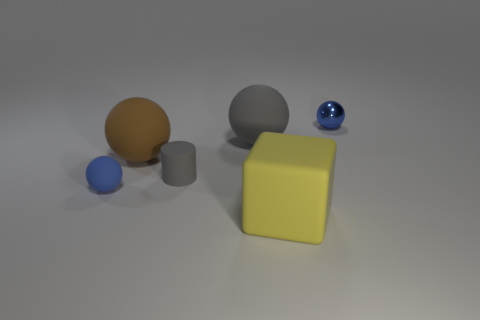Subtract all large brown balls. How many balls are left? 3 Add 2 brown balls. How many objects exist? 8 Subtract all gray cylinders. How many blue balls are left? 2 Subtract 1 blocks. How many blocks are left? 0 Subtract all cylinders. How many objects are left? 5 Subtract all blue spheres. How many spheres are left? 2 Subtract 1 brown spheres. How many objects are left? 5 Subtract all brown spheres. Subtract all blue cubes. How many spheres are left? 3 Subtract all small gray matte objects. Subtract all large red shiny cylinders. How many objects are left? 5 Add 6 tiny metal balls. How many tiny metal balls are left? 7 